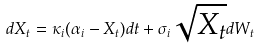Convert formula to latex. <formula><loc_0><loc_0><loc_500><loc_500>d X _ { t } = \kappa _ { i } ( \alpha _ { i } - X _ { t } ) d t + \sigma _ { i } \sqrt { X _ { t } } d W _ { t }</formula> 